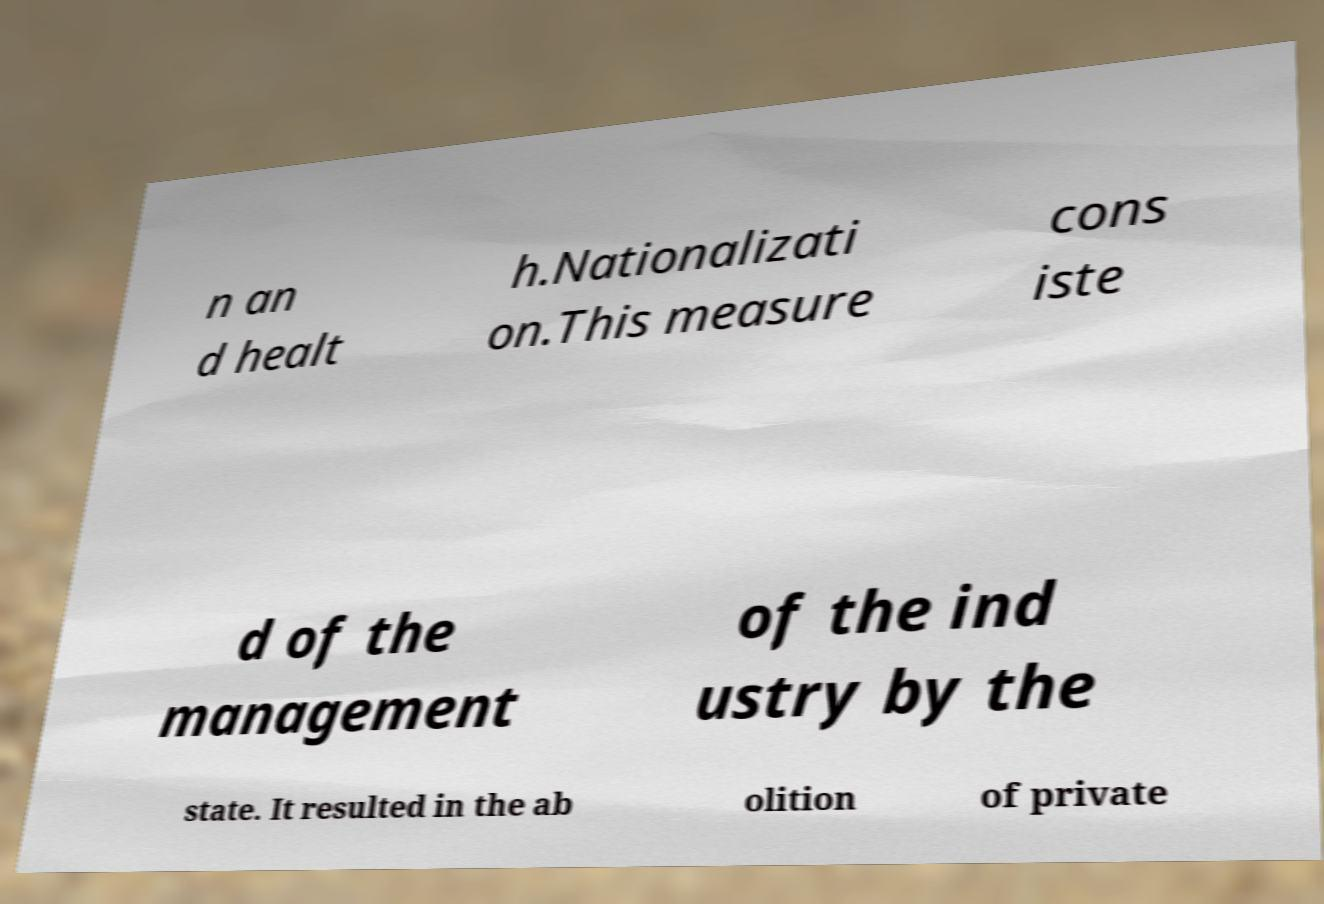Could you assist in decoding the text presented in this image and type it out clearly? n an d healt h.Nationalizati on.This measure cons iste d of the management of the ind ustry by the state. It resulted in the ab olition of private 